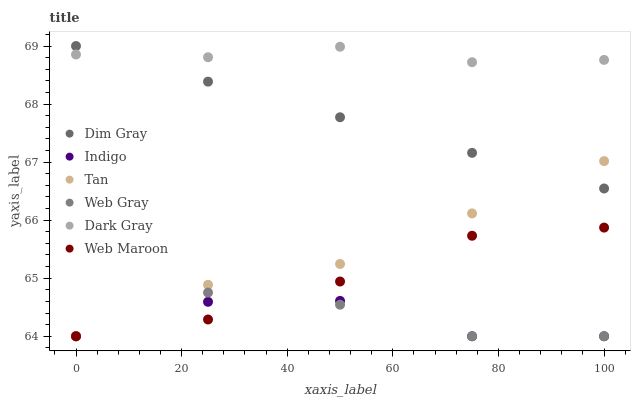Does Indigo have the minimum area under the curve?
Answer yes or no. Yes. Does Dark Gray have the maximum area under the curve?
Answer yes or no. Yes. Does Web Maroon have the minimum area under the curve?
Answer yes or no. No. Does Web Maroon have the maximum area under the curve?
Answer yes or no. No. Is Dim Gray the smoothest?
Answer yes or no. Yes. Is Web Gray the roughest?
Answer yes or no. Yes. Is Indigo the smoothest?
Answer yes or no. No. Is Indigo the roughest?
Answer yes or no. No. Does Web Gray have the lowest value?
Answer yes or no. Yes. Does Dark Gray have the lowest value?
Answer yes or no. No. Does Dim Gray have the highest value?
Answer yes or no. Yes. Does Web Maroon have the highest value?
Answer yes or no. No. Is Web Gray less than Dark Gray?
Answer yes or no. Yes. Is Dim Gray greater than Web Gray?
Answer yes or no. Yes. Does Dark Gray intersect Dim Gray?
Answer yes or no. Yes. Is Dark Gray less than Dim Gray?
Answer yes or no. No. Is Dark Gray greater than Dim Gray?
Answer yes or no. No. Does Web Gray intersect Dark Gray?
Answer yes or no. No. 